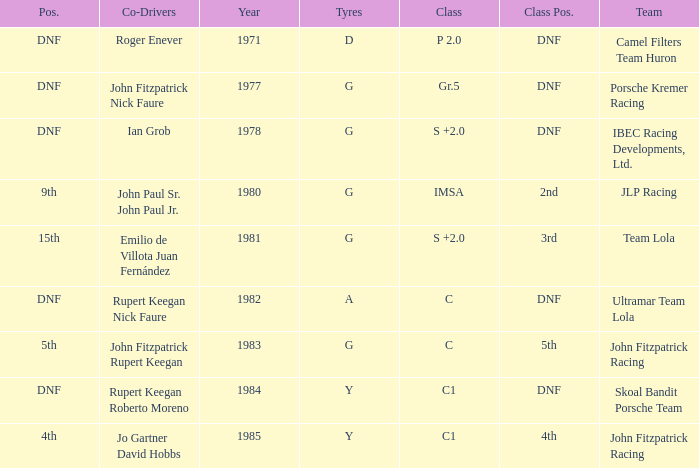What is the earliest year that had a co-driver of Roger Enever? 1971.0. 